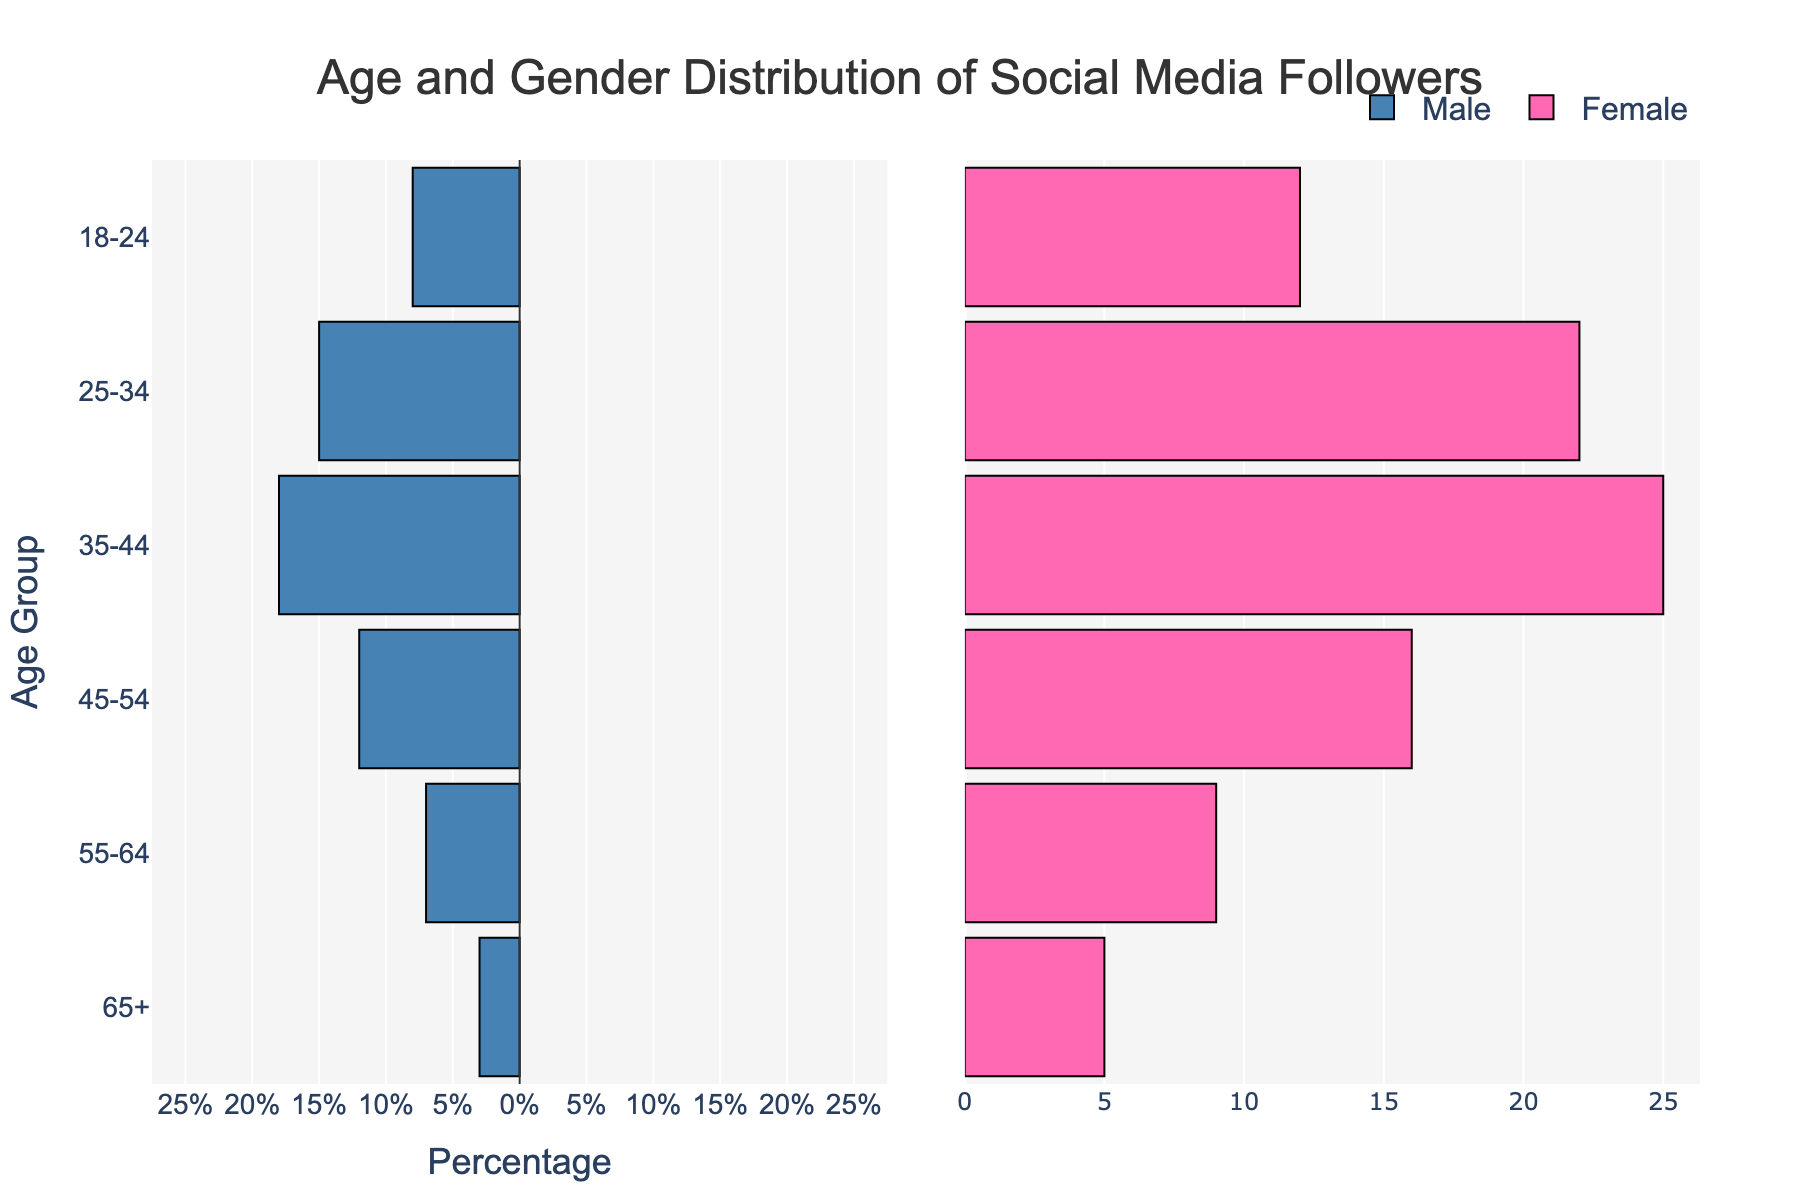What is the title of the figure? The title is located at the top of the figure and generally summarizes what the figure is about. It reads 'Age and Gender Distribution of Social Media Followers'.
Answer: Age and Gender Distribution of Social Media Followers What are the colors used to represent Male and Female? The colors can be observed from the bars in the figure. Males are represented with a color similar to blue, and Females are represented with a color similar to pink.
Answer: Blue and Pink Which age group has the highest number of Female followers? By examining the lengths of the bars for Female followers, the age group 35-44 shows the longest bar.
Answer: 35-44 Compare the number of Male and Female followers within the age group 25-34. Which gender has more followers? The figure shows that the bar for Female followers is longer than that for Male followers in the age group 25-34.
Answer: Female How many age groups are represented in the figure? The age groups are indicated on the y-axis and can be counted individually. There are 6 age groups.
Answer: 6 In which age group do Male followers outnumber Female followers? By comparing the lengths of the bars within each age group, it's evident that for the age group 35-44, Male followers outnumber Female followers.
Answer: 35-44 What is the difference between the number of Female followers in the age group 25-34 and 45-54? By comparing the lengths of the bars, the number of Female followers in 25-34 is 22, and in 45-54 is 16. The difference is 22 - 16 = 6.
Answer: 6 What is the sum of Male followers in the age groups 18-24 and 65+? By adding the values from the bars: 8 (18-24) + 3 (65+) = 11.
Answer: 11 What can you infer about the age distribution of social media followers from the figure? The figure shows that most followers fall within the middle age groups (25-34 and 35-44), with fewer followers in the youngest (18-24) and oldest (65+) age groups.
Answer: Most followers are in the middle age groups (25-44) What is the overall trend observed in the difference between Male and Female followers as age increases? By examining the length comparison of bars within each age group, it can be observed that Female followers consistently outnumber Male followers across all age groups, with the gap widening in the middle age groups (25-44).
Answer: Female followers consistently outnumber Male followers 